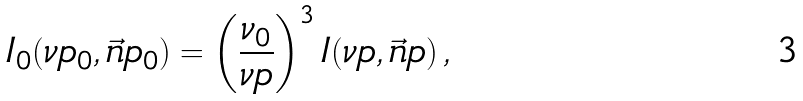<formula> <loc_0><loc_0><loc_500><loc_500>I _ { 0 } ( \nu p _ { 0 } , \vec { n } p _ { 0 } ) = \left ( \frac { \nu _ { 0 } } { \nu p } \right ) ^ { 3 } I ( \nu p , \vec { n } p ) \, ,</formula> 